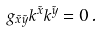Convert formula to latex. <formula><loc_0><loc_0><loc_500><loc_500>g _ { \tilde { x } \tilde { y } } k ^ { \tilde { x } } k ^ { \tilde { y } } = 0 \, .</formula> 